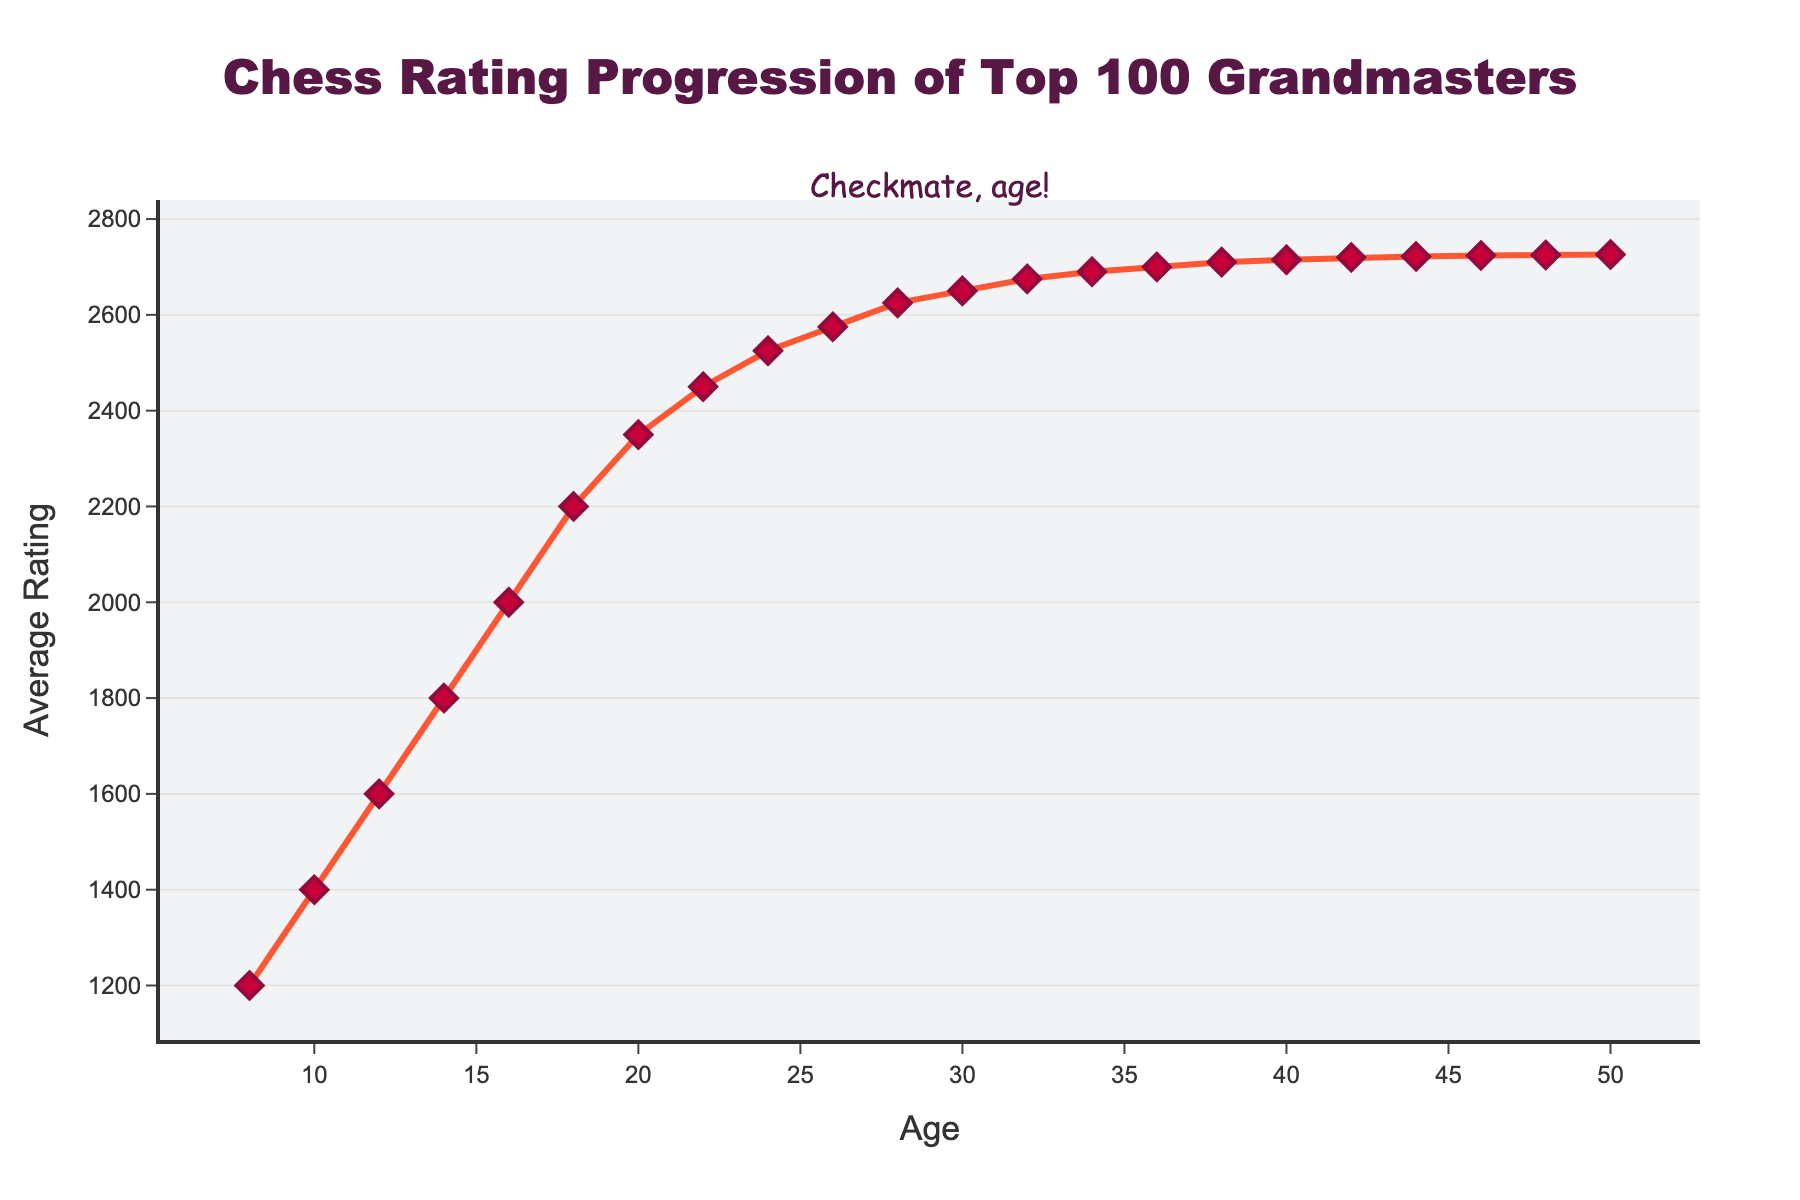What's the average rating at age 20? To find the average rating at age 20, simply refer to the data point on the chart where the age is 20.
Answer: 2350 Between which ages does the greatest increase in average rating occur? Observe the slopes between connected points on the graph. The steepest slope represents the greatest increase. The steepest part seems to be between ages 18 and 20.
Answer: 18 to 20 How much does the average rating increase from age 8 to age 12? Look at the ratings at ages 8 and 12. Subtract the rating at age 8 (1200) from the rating at age 12 (1600).
Answer: 400 What is the average rating at the peak performance age? To find the peak performance age, identify the highest point on the graph and read the rating. The highest point is at age 50, with a rating of 2726.
Answer: 2726 At what age does the average rating first surpass 2500? Follow the ratings along the age axis until you find the first point where the rating is above 2500. This occurs at age 24.
Answer: 24 At age 30, how much has the average rating increased since age 20? Find the ratings at ages 20 and 30. Subtract the rating at age 20 (2350) from the rating at age 30 (2650).
Answer: 300 What is the overall trend of the average rating as age increases from 8 to 50? Observing the general direction of the line from the start (age 8) to the end (age 50), the average rating progressively increases over this age range.
Answer: Increases Does the rating increase more rapidly in the earlier years (ages 8-20) or in the later years (ages 30-50)? Compare the slopes (steepness) of the line between ages 8-20 and 30-50. The line is steeper in the early years.
Answer: Earlier years (8-20) At what age does the average rating reach 2700? Find the point on the graph where the rating hits 2700. This happens at age 36.
Answer: 36 